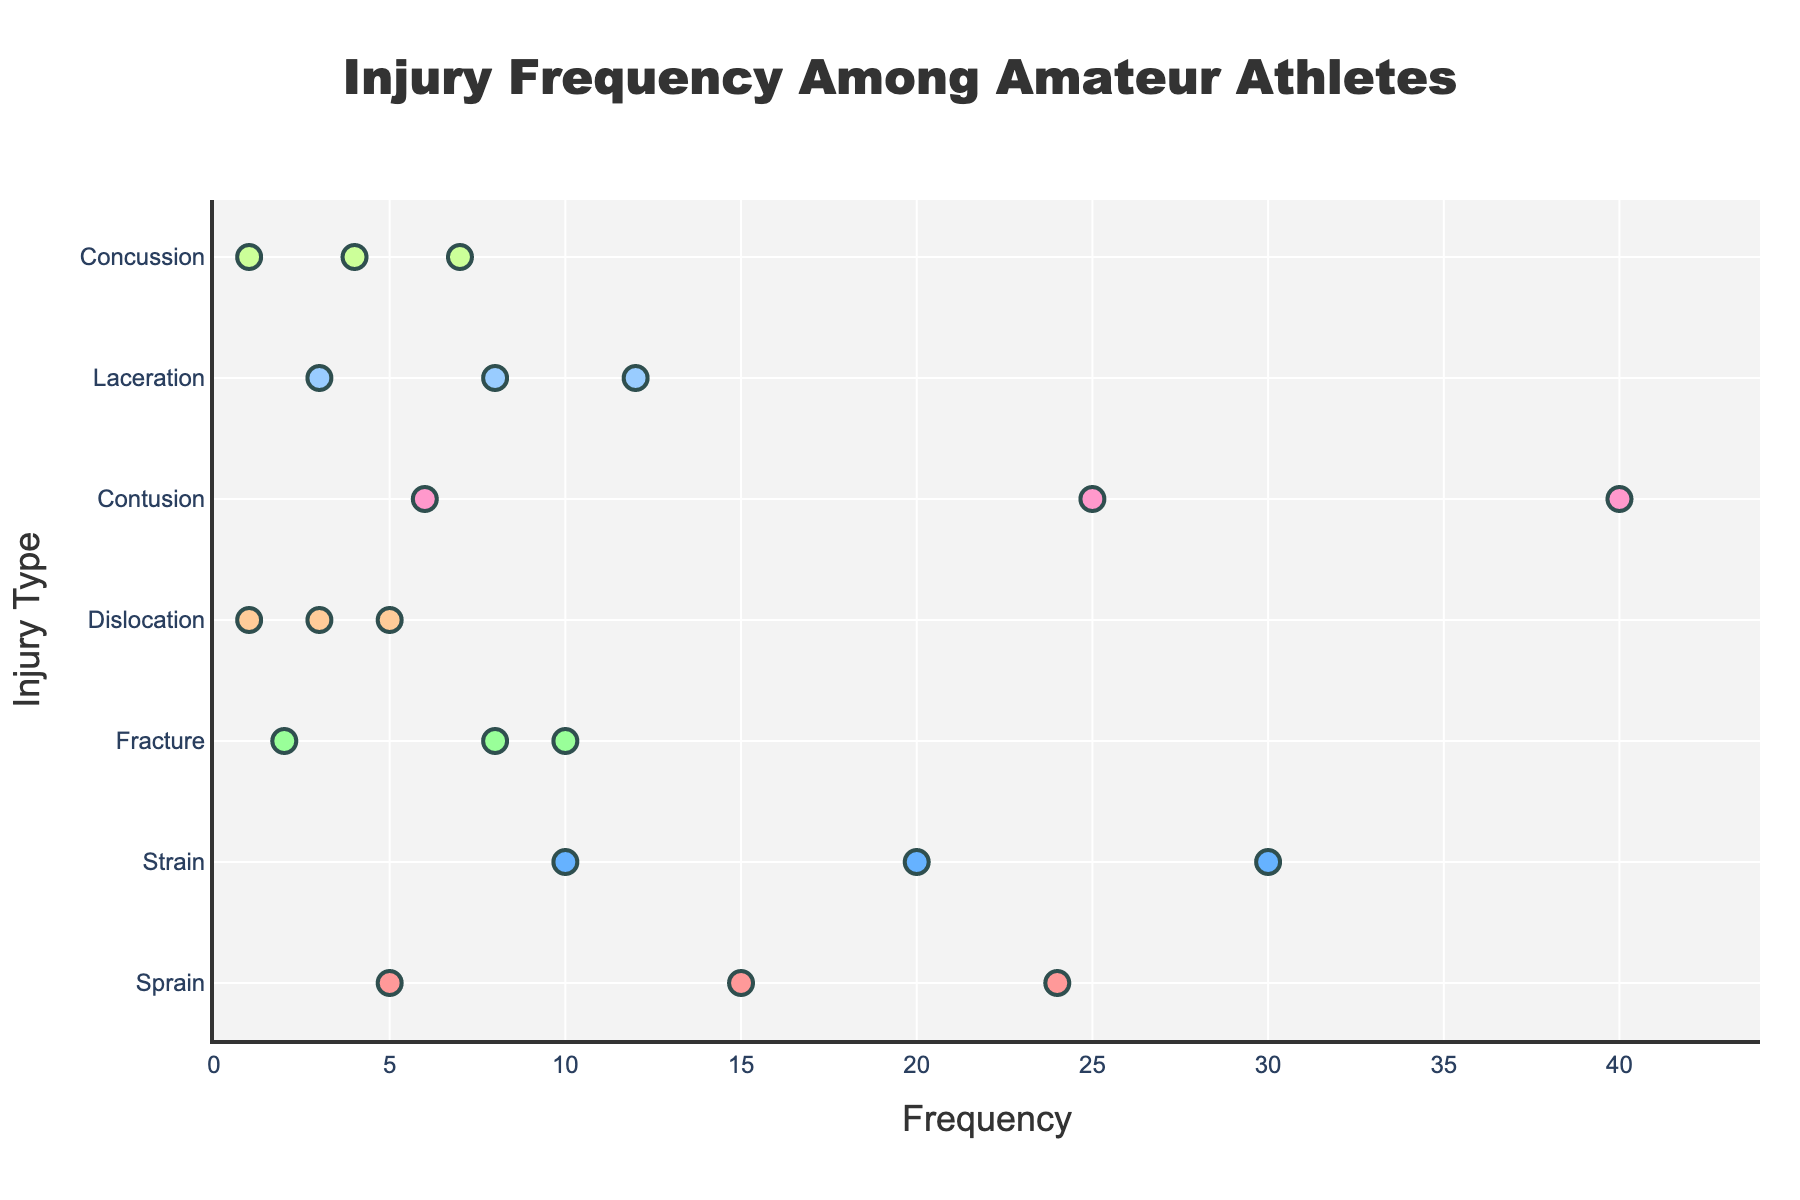How many types of injuries are represented in the plot? The figure lists different types of injuries on the y-axis. By counting these unique types, we can determine the number of distinct injury types.
Answer: 7 Which injury type has the highest frequency for mild severity? The x-axis represents frequency, and we look for the maximum x-coordinate among mild severities across different injury types. The injury with the largest value is identified.
Answer: Contusion What is the total frequency of severe injuries for Sprain and Strain combined? Find the frequencies of severe Sprain and Strain injuries (5 and 10, respectively) and add them together: 5 + 10 = 15.
Answer: 15 Which injury type has the lowest frequency for severe severity? The x-axis represents frequency and the data points with severe severities are considered. The minimum x-coordinate value among them will indicate the lowest frequency.
Answer: Dislocation or Concussion Compare the frequencies of moderate and severe strains. Is one greater than the other? Look at the frequencies for moderate and severe Strain data points (20 and 10, respectively) and compare them: 20 > 10.
Answer: Moderate is greater What is the average frequency of mild injuries across all types? Sum up the frequencies of mild injuries from all types: 24 (Sprain) + 30 (Strain) + 10 (Fracture) + 5 (Dislocation) + 40 (Contusion) + 12 (Laceration) + 7 (Concussion) = 128. The average is 128 / 7 ≈ 18.29.
Answer: 18.29 Which injury type has the closest mild frequency to the frequency of moderate laceration? Compare the mild frequencies of all injury types to the moderate frequency of Laceration (8) and find the one that is closest.
Answer: Concussion (7) Which injury type has the widest range between mild and severe frequencies? For each injury type, subtract the severe frequency from the mild frequency. Identify the type with the maximum difference. For Contusion: 40 - 6 = 34, etc.
Answer: Contusion How do the total frequencies of moderate injuries compare to that of severe injuries? Sum up the frequencies of moderate and severe injuries separately. Moderate: 15+20+8+3+25+8+4 = 83. Severe: 5+10+2+1+6+3+1 = 28. Compare the sums: 83 > 28.
Answer: Moderate is greater 